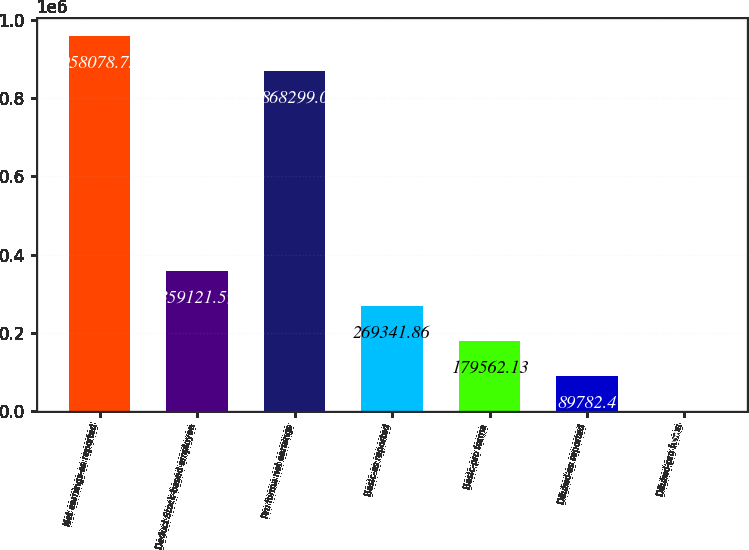Convert chart to OTSL. <chart><loc_0><loc_0><loc_500><loc_500><bar_chart><fcel>Net earnings-as reported<fcel>Deduct Stock-based employee<fcel>Pro forma net earnings<fcel>Basic-as reported<fcel>Basic-pro forma<fcel>Diluted-as reported<fcel>Diluted-pro forma<nl><fcel>958079<fcel>359122<fcel>868299<fcel>269342<fcel>179562<fcel>89782.4<fcel>2.67<nl></chart> 